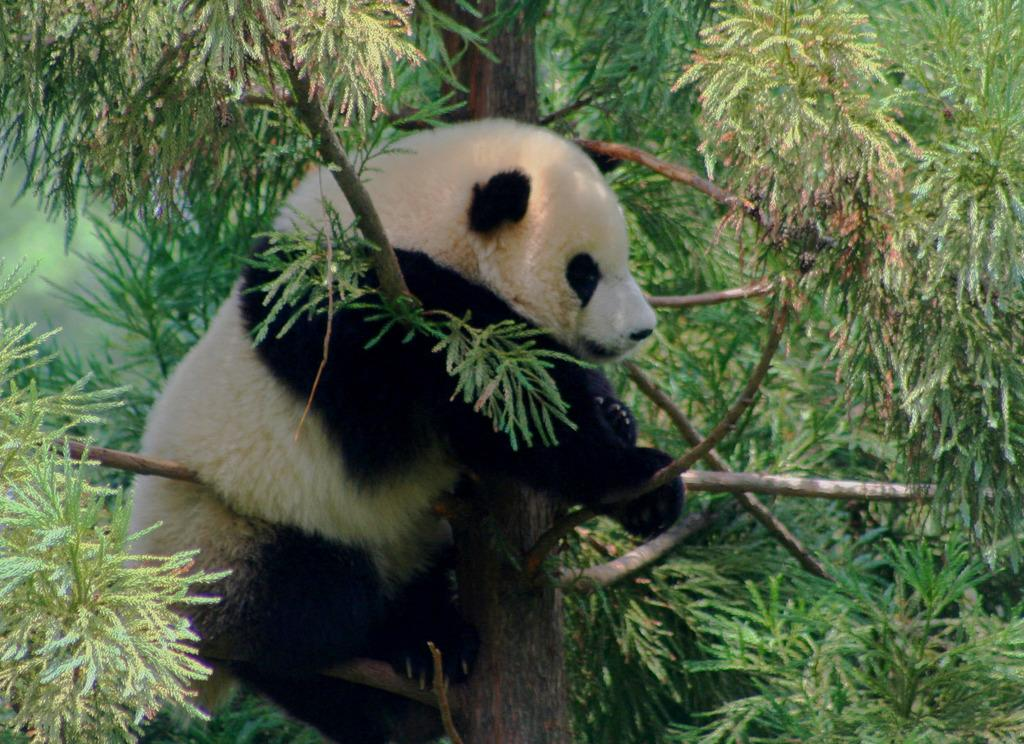What animal is present in the image? There is a panda in the image. Where is the panda located? The panda is on a tree. What type of vegetation can be seen in the background of the image? There are stems with green leaves in the background of the image. What type of headwear is the panda wearing in the image? The panda is not wearing any headwear in the image. Can you see a zipper on the tree where the panda is located? There is no zipper present on the tree or anywhere else in the image. 